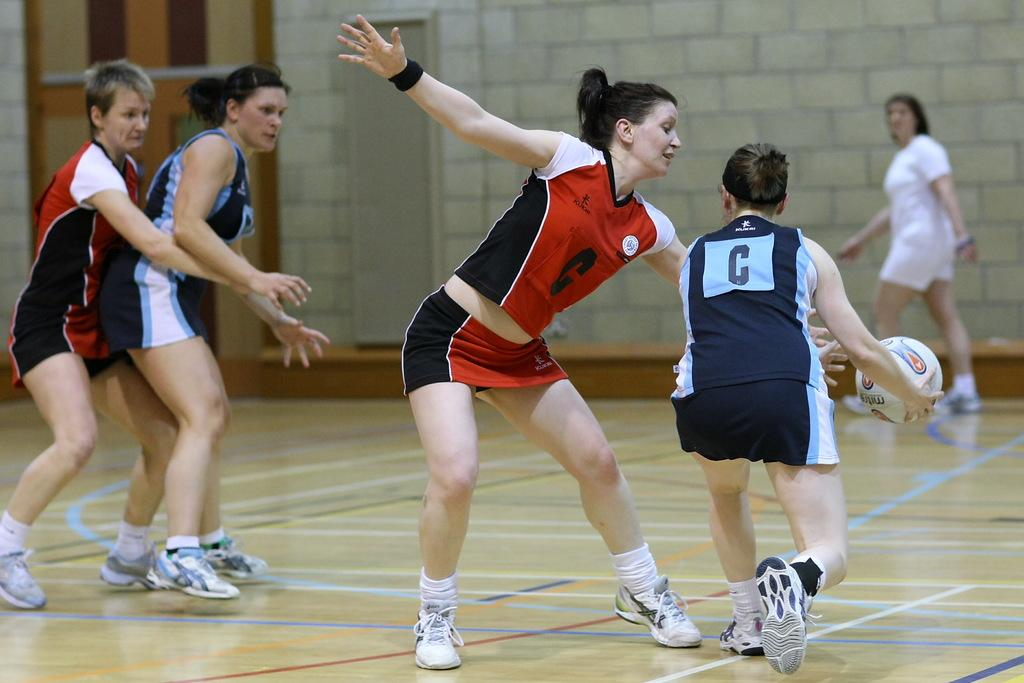Provide a one-sentence caption for the provided image. A female athlete wearing red, with the letter C on the front, is trying to block another female athlete, with a ball, from getting past her. 